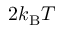<formula> <loc_0><loc_0><loc_500><loc_500>2 k _ { B } T</formula> 